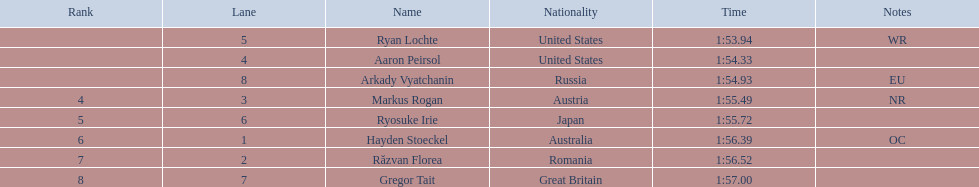Write the full table. {'header': ['Rank', 'Lane', 'Name', 'Nationality', 'Time', 'Notes'], 'rows': [['', '5', 'Ryan Lochte', 'United States', '1:53.94', 'WR'], ['', '4', 'Aaron Peirsol', 'United States', '1:54.33', ''], ['', '8', 'Arkady Vyatchanin', 'Russia', '1:54.93', 'EU'], ['4', '3', 'Markus Rogan', 'Austria', '1:55.49', 'NR'], ['5', '6', 'Ryosuke Irie', 'Japan', '1:55.72', ''], ['6', '1', 'Hayden Stoeckel', 'Australia', '1:56.39', 'OC'], ['7', '2', 'Răzvan Florea', 'Romania', '1:56.52', ''], ['8', '7', 'Gregor Tait', 'Great Britain', '1:57.00', '']]} What is the total number of names mentioned? 8. 